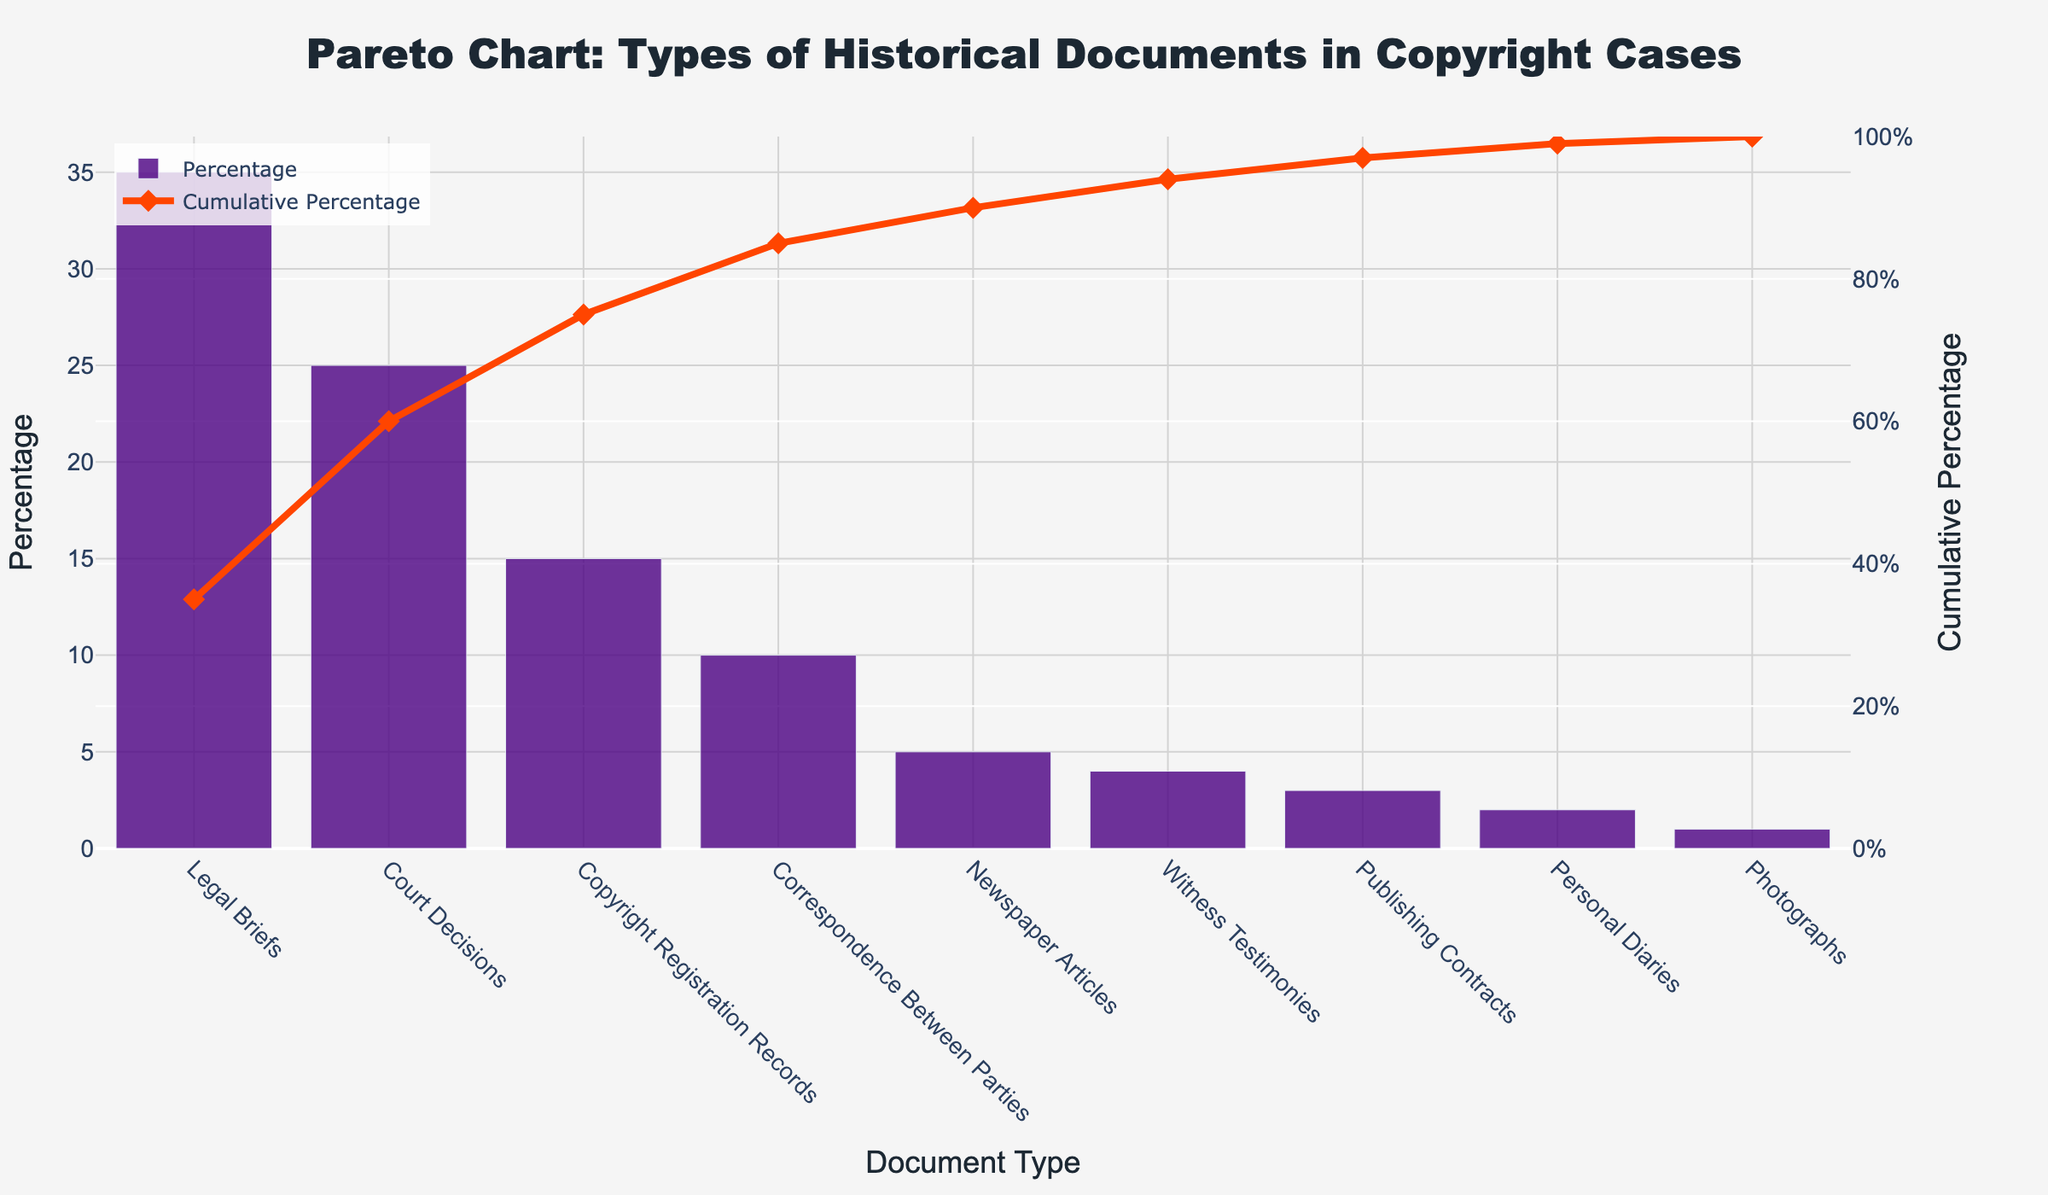How many types of historical documents are plotted in the figure? Count the number of unique document types listed along the x-axis.
Answer: 9 Which document type has the highest percentage? Identify the document type with the tallest bar in the bar chart.
Answer: Legal Briefs What is the cumulative percentage after including the top three document types? Sum the percentages of the top three document types: Legal Briefs (35%), Court Decisions (25%), and Copyright Registration Records (15%), and then calculate the cumulative percentage.
Answer: 75% What percentage of documents do Legal Briefs and Court Decisions together represent? Add the percentages of Legal Briefs (35%) and Court Decisions (25%).
Answer: 60% Which type of document has a higher percentage, Newspaper Articles or Witness Testimonies? Compare the heights of the bars representing Newspaper Articles and Witness Testimonies.
Answer: Newspaper Articles What is the cumulative percentage for the first five document types? Sum the percentages of the first five document types and note the cumulative percentage shown by the line chart. The document types are Legal Briefs (35%), Court Decisions (25%), Copyright Registration Records (15%), Correspondence Between Parties (10%), and Newspaper Articles (5%).
Answer: 90% How many document types have a percentage below 5%? Identify and count the bars representing document types with heights less than 5%.
Answer: 4 Does the cumulative percentage line reach 100% before including all document types? Check the line chart’s cumulative percentage against the x-axis and see if it hits 100% before the last document type.
Answer: No Which document type appears last in the order presented in the figure? Look at the last document type on the x-axis.
Answer: Photographs 